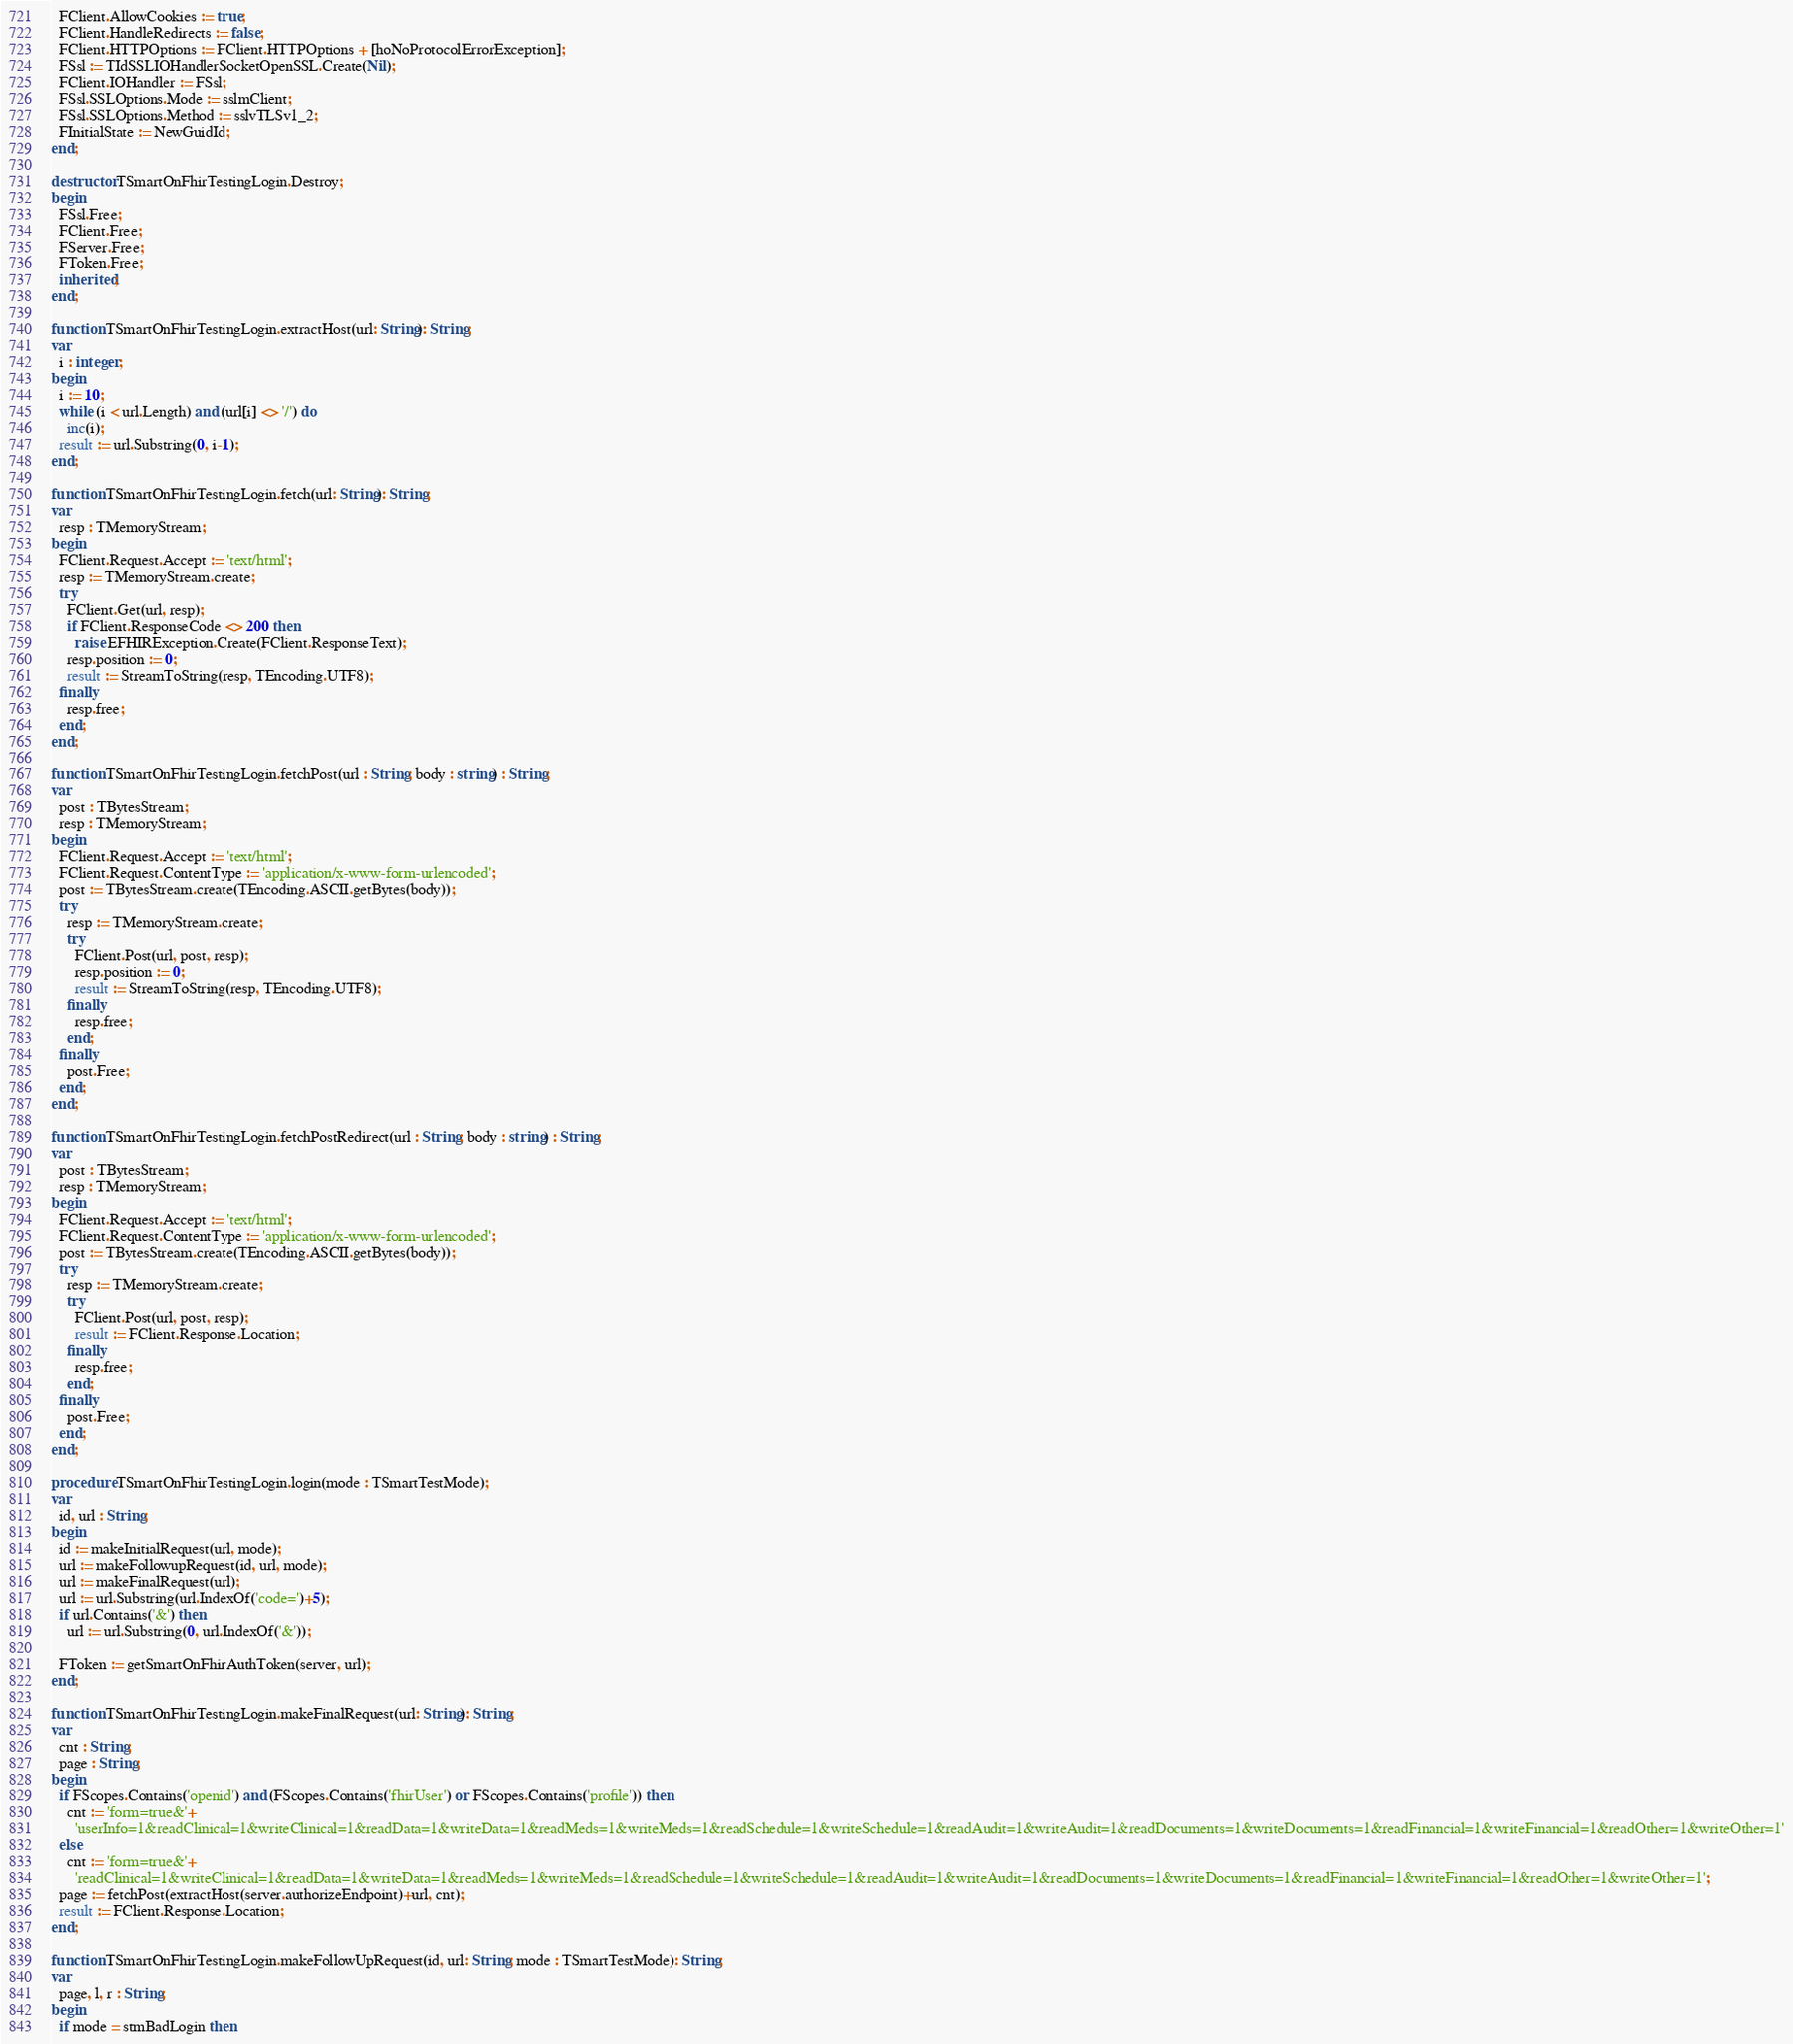<code> <loc_0><loc_0><loc_500><loc_500><_Pascal_>  FClient.AllowCookies := true;
  FClient.HandleRedirects := false;
  FClient.HTTPOptions := FClient.HTTPOptions + [hoNoProtocolErrorException];
  FSsl := TIdSSLIOHandlerSocketOpenSSL.Create(Nil);
  FClient.IOHandler := FSsl;
  FSsl.SSLOptions.Mode := sslmClient;
  FSsl.SSLOptions.Method := sslvTLSv1_2;
  FInitialState := NewGuidId;
end;

destructor TSmartOnFhirTestingLogin.Destroy;
begin
  FSsl.Free;
  FClient.Free;
  FServer.Free;
  FToken.Free;
  inherited;
end;

function TSmartOnFhirTestingLogin.extractHost(url: String): String;
var
  i : integer;
begin
  i := 10;
  while (i < url.Length) and (url[i] <> '/') do
    inc(i);
  result := url.Substring(0, i-1);
end;

function TSmartOnFhirTestingLogin.fetch(url: String): String;
var
  resp : TMemoryStream;
begin
  FClient.Request.Accept := 'text/html';
  resp := TMemoryStream.create;
  try
    FClient.Get(url, resp);
    if FClient.ResponseCode <> 200 then
      raise EFHIRException.Create(FClient.ResponseText);
    resp.position := 0;
    result := StreamToString(resp, TEncoding.UTF8);
  finally
    resp.free;
  end;
end;

function TSmartOnFhirTestingLogin.fetchPost(url : String; body : string) : String;
var
  post : TBytesStream;
  resp : TMemoryStream;
begin
  FClient.Request.Accept := 'text/html';
  FClient.Request.ContentType := 'application/x-www-form-urlencoded';
  post := TBytesStream.create(TEncoding.ASCII.getBytes(body));
  try
    resp := TMemoryStream.create;
    try
      FClient.Post(url, post, resp);
      resp.position := 0;
      result := StreamToString(resp, TEncoding.UTF8);
    finally
      resp.free;
    end;
  finally
    post.Free;
  end;
end;

function TSmartOnFhirTestingLogin.fetchPostRedirect(url : String; body : string) : String;
var
  post : TBytesStream;
  resp : TMemoryStream;
begin
  FClient.Request.Accept := 'text/html';
  FClient.Request.ContentType := 'application/x-www-form-urlencoded';
  post := TBytesStream.create(TEncoding.ASCII.getBytes(body));
  try
    resp := TMemoryStream.create;
    try
      FClient.Post(url, post, resp);
      result := FClient.Response.Location;
    finally
      resp.free;
    end;
  finally
    post.Free;
  end;
end;

procedure TSmartOnFhirTestingLogin.login(mode : TSmartTestMode);
var
  id, url : String;
begin
  id := makeInitialRequest(url, mode);
  url := makeFollowupRequest(id, url, mode);
  url := makeFinalRequest(url);
  url := url.Substring(url.IndexOf('code=')+5);
  if url.Contains('&') then
    url := url.Substring(0, url.IndexOf('&'));

  FToken := getSmartOnFhirAuthToken(server, url);
end;

function TSmartOnFhirTestingLogin.makeFinalRequest(url: String): String;
var
  cnt : String;
  page : String;
begin
  if FScopes.Contains('openid') and (FScopes.Contains('fhirUser') or FScopes.Contains('profile')) then
    cnt := 'form=true&'+
      'userInfo=1&readClinical=1&writeClinical=1&readData=1&writeData=1&readMeds=1&writeMeds=1&readSchedule=1&writeSchedule=1&readAudit=1&writeAudit=1&readDocuments=1&writeDocuments=1&readFinancial=1&writeFinancial=1&readOther=1&writeOther=1'
  else
    cnt := 'form=true&'+
      'readClinical=1&writeClinical=1&readData=1&writeData=1&readMeds=1&writeMeds=1&readSchedule=1&writeSchedule=1&readAudit=1&writeAudit=1&readDocuments=1&writeDocuments=1&readFinancial=1&writeFinancial=1&readOther=1&writeOther=1';
  page := fetchPost(extractHost(server.authorizeEndpoint)+url, cnt);
  result := FClient.Response.Location;
end;

function TSmartOnFhirTestingLogin.makeFollowUpRequest(id, url: String; mode : TSmartTestMode): String;
var
  page, l, r : String;
begin
  if mode = stmBadLogin then</code> 